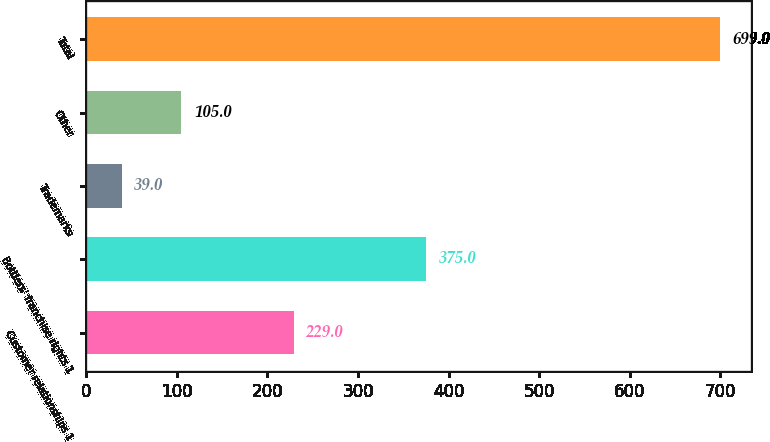Convert chart to OTSL. <chart><loc_0><loc_0><loc_500><loc_500><bar_chart><fcel>Customer relationships 1<fcel>Bottlers' franchise rights 1<fcel>Trademarks<fcel>Other<fcel>Total<nl><fcel>229<fcel>375<fcel>39<fcel>105<fcel>699<nl></chart> 